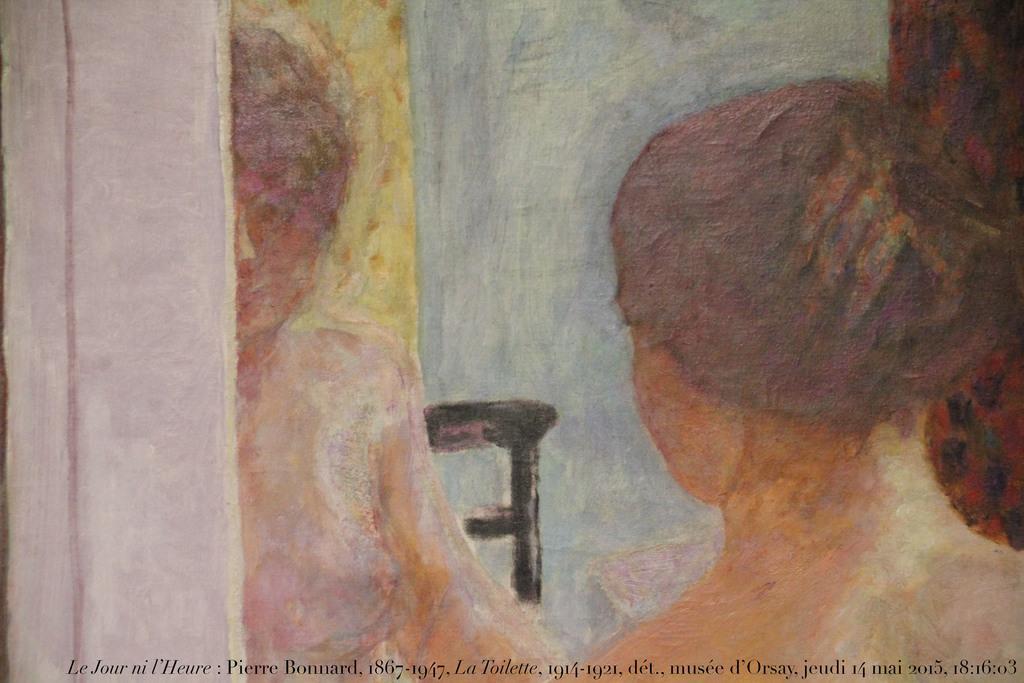Please provide a concise description of this image. This is a picture of a painting of a person , and there is a watermark on the image. 